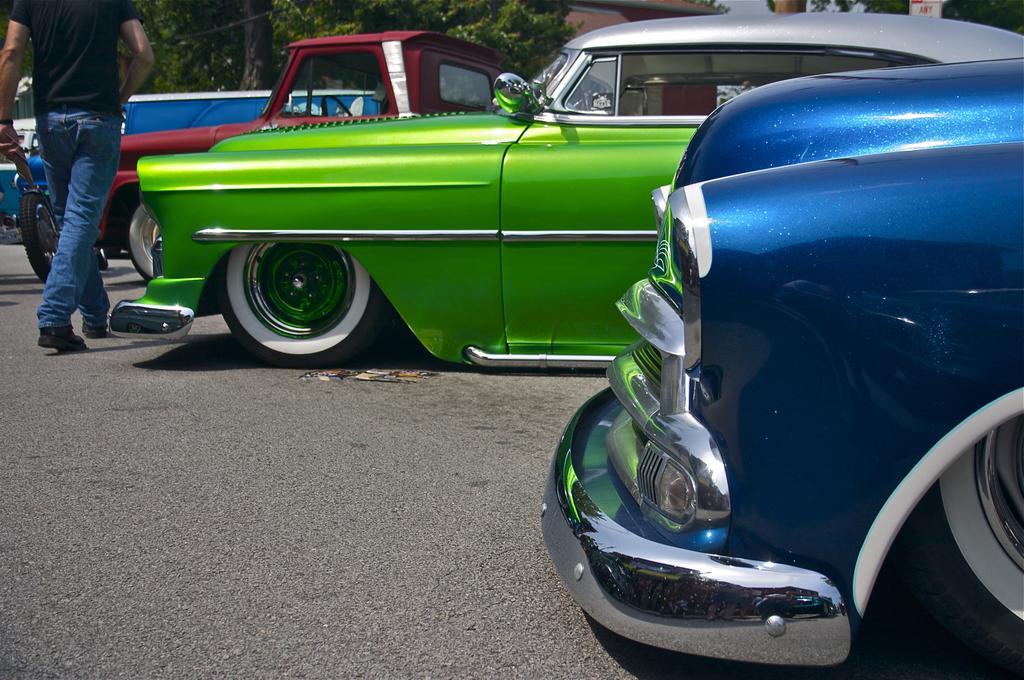Describe this image in one or two sentences. In this picture there is a man who is wearing black t-shirt, jeans and standing near to the green car. He is holding tire. On the right there is a car on the road. In the background we can see truck, van and car near to the trees. At the top we can see sky and stones. 